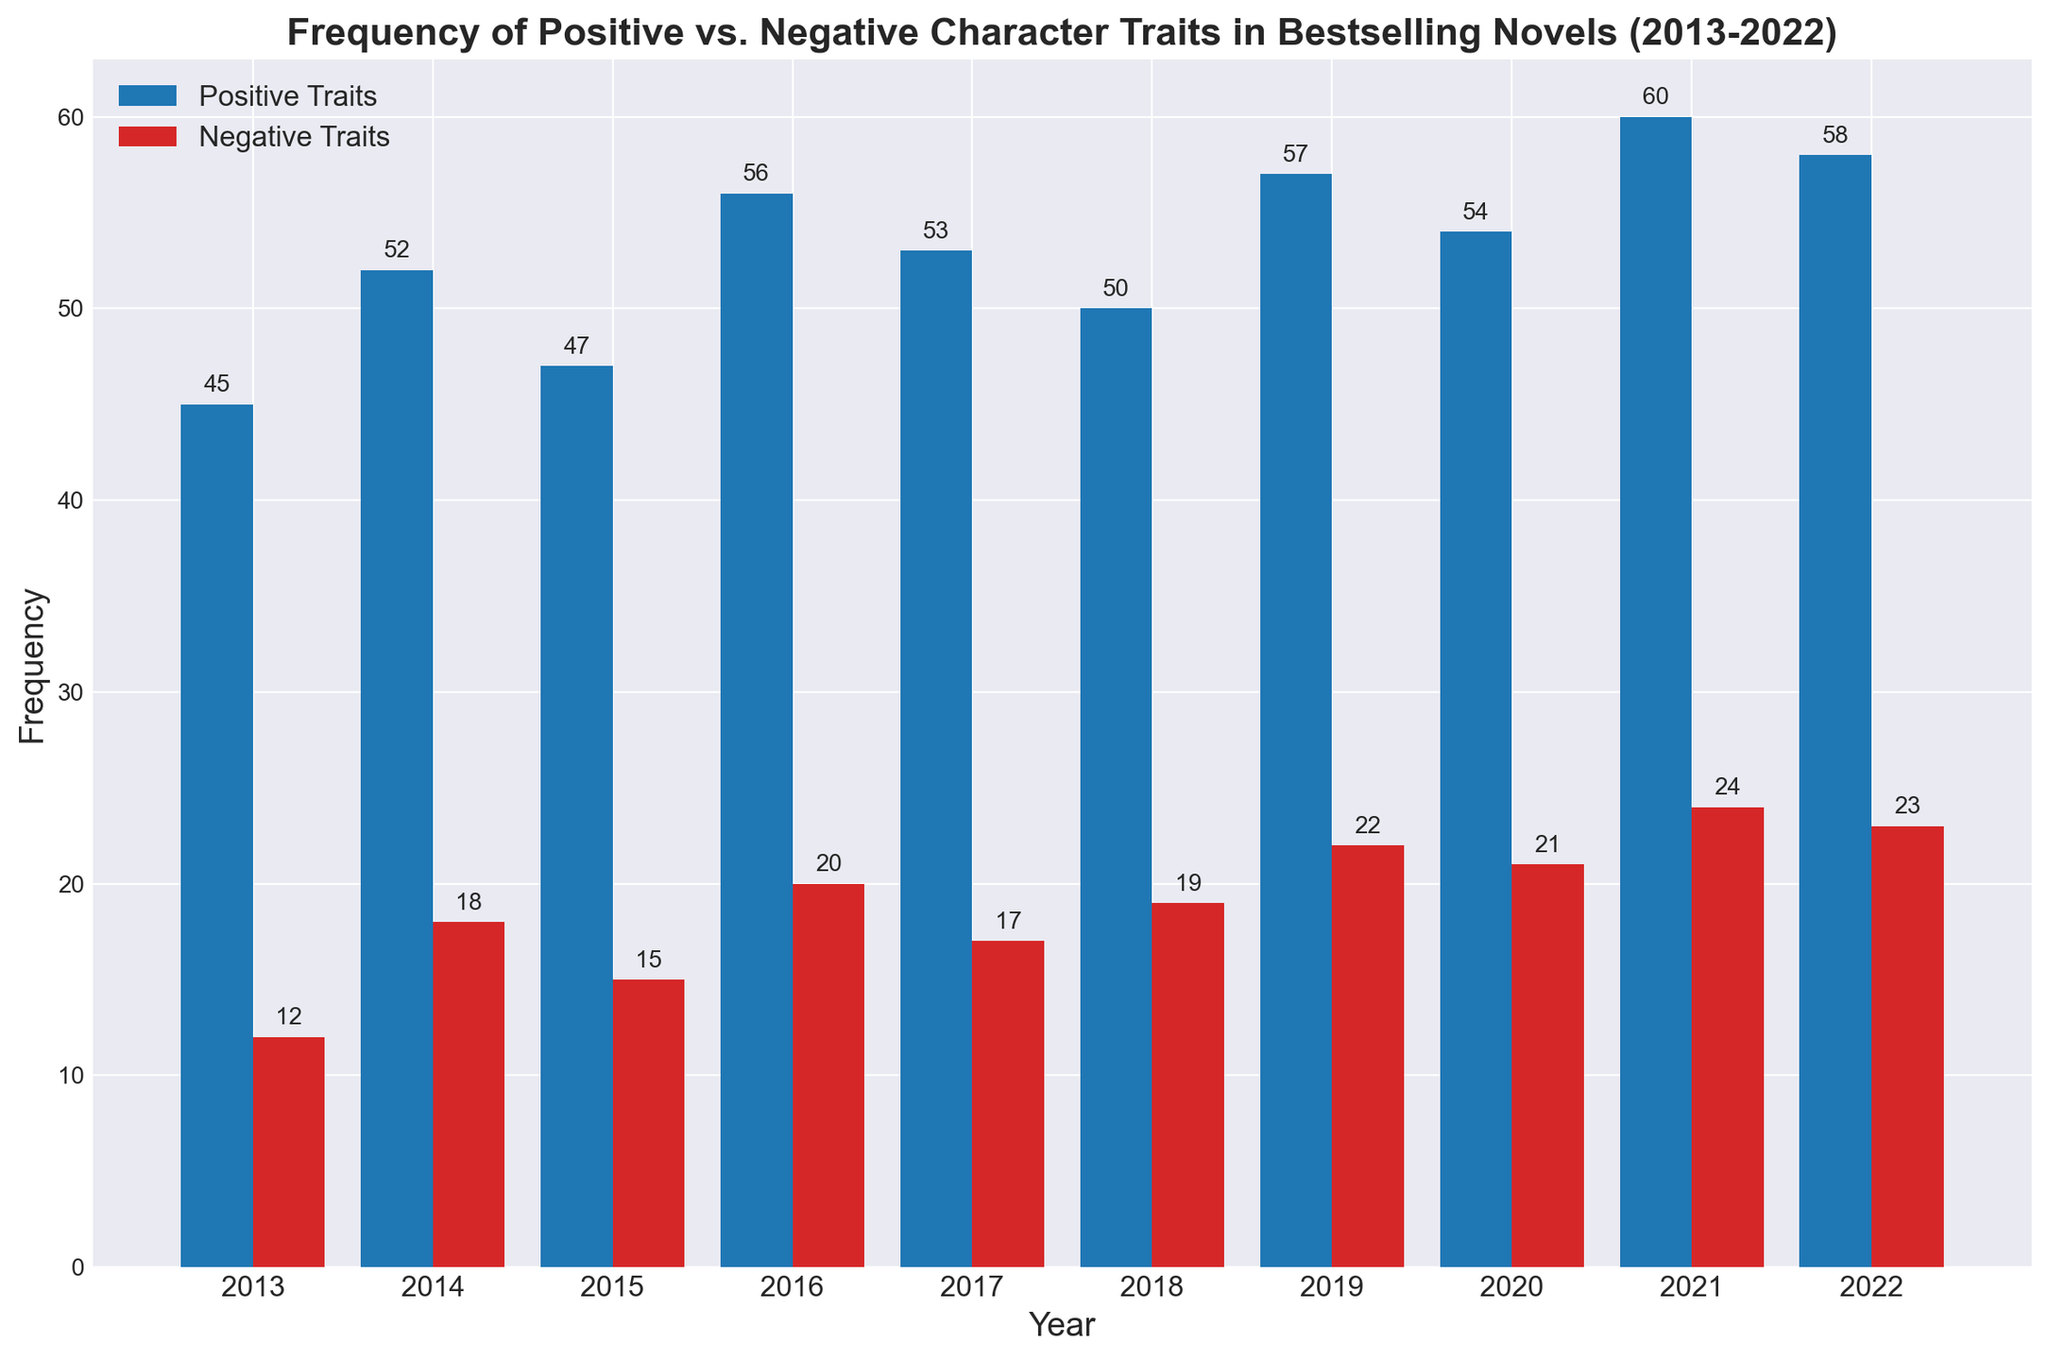Which year had the highest frequency of positive traits? By observing the height of the bars representing positive traits, the tallest bar indicates the highest frequency. The bar for 2021 is the tallest among all years, showing that 2021 had the highest frequency of positive traits.
Answer: 2021 Compare 2014 and 2018: Which year had a higher frequency of negative traits and by how much? Both years have bars representing negative traits. By comparing their heights, we see that 2014 has 18 and 2018 has 19 negative traits. Therefore, 2018 had 1 more negative trait than 2014.
Answer: 2018 by 1 What's the average frequency of positive traits over the decade? Adding all the values from 2013 to 2022 (45 + 52 + 47 + 56 + 53 + 50 + 57 + 54 + 60 + 58) gives a total of 532. Dividing this by 10 (the number of years) results in an average of 53.2.
Answer: 53.2 How many more positive traits were there than negative traits in 2019? For 2019, the positive traits are 57 and the negative traits are 22. Subtracting the negative traits from the positive traits (57 - 22) gives the difference.
Answer: 35 Which year had the smallest difference between positive and negative traits? Calculating the difference for each year and comparing them:
2013: 45 - 12 = 33
2014: 52 - 18 = 34
2015: 47 - 15 = 32
2016: 56 - 20 = 36
2017: 53 - 17 = 36
2018: 50 - 19 = 31
2019: 57 - 22 = 35
2020: 54 - 21 = 33
2021: 60 - 24 = 36
2022: 58 - 23 = 35
The smallest difference is for 2018 with 31.
Answer: 2018 What is the trend of positive traits from 2013 to 2022? Observing the positive traits' bar heights over the years from left to right, there is a general upward trend with some fluctuations, indicating an overall increase in the frequency of positive traits.
Answer: Increasing trend Which year showed an equal increase in positive and negative traits compared to the previous year? Comparing the yearly frequencies:
2013 to 2014: +7 (45 to 52) positive, +6 (12 to 18) negative
2014 to 2015: -5 (52 to 47) positive, -3 (18 to 15) negative
2015 to 2016: +9 (47 to 56) positive, +5 (15 to 20) negative
2016 to 2017: -3 (56 to 53) positive, -3 (20 to 17) negative
2017 to 2018: -3 (53 to 50) positive, +2 (17 to 19) negative
2018 to 2019: +7 (50 to 57) positive, +3 (19 to 22) negative
2019 to 2020: -3 (57 to 54) positive, -1 (22 to 21) negative
2020 to 2021: +6 (54 to 60) positive, +3 (21 to 24) negative
2021 to 2022: -2 (60 to 58) positive, -1 (24 to 23) negative
No year shows an equal increase in both traits.
Answer: None What's the sum of negative traits over the years 2015 and 2016? Adding the negative traits for 2015 and 2016 (15 + 20) gives the total.
Answer: 35 